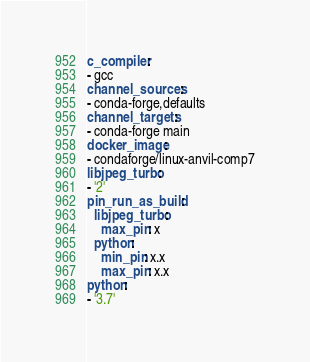<code> <loc_0><loc_0><loc_500><loc_500><_YAML_>c_compiler:
- gcc
channel_sources:
- conda-forge,defaults
channel_targets:
- conda-forge main
docker_image:
- condaforge/linux-anvil-comp7
libjpeg_turbo:
- '2'
pin_run_as_build:
  libjpeg_turbo:
    max_pin: x
  python:
    min_pin: x.x
    max_pin: x.x
python:
- '3.7'
</code> 